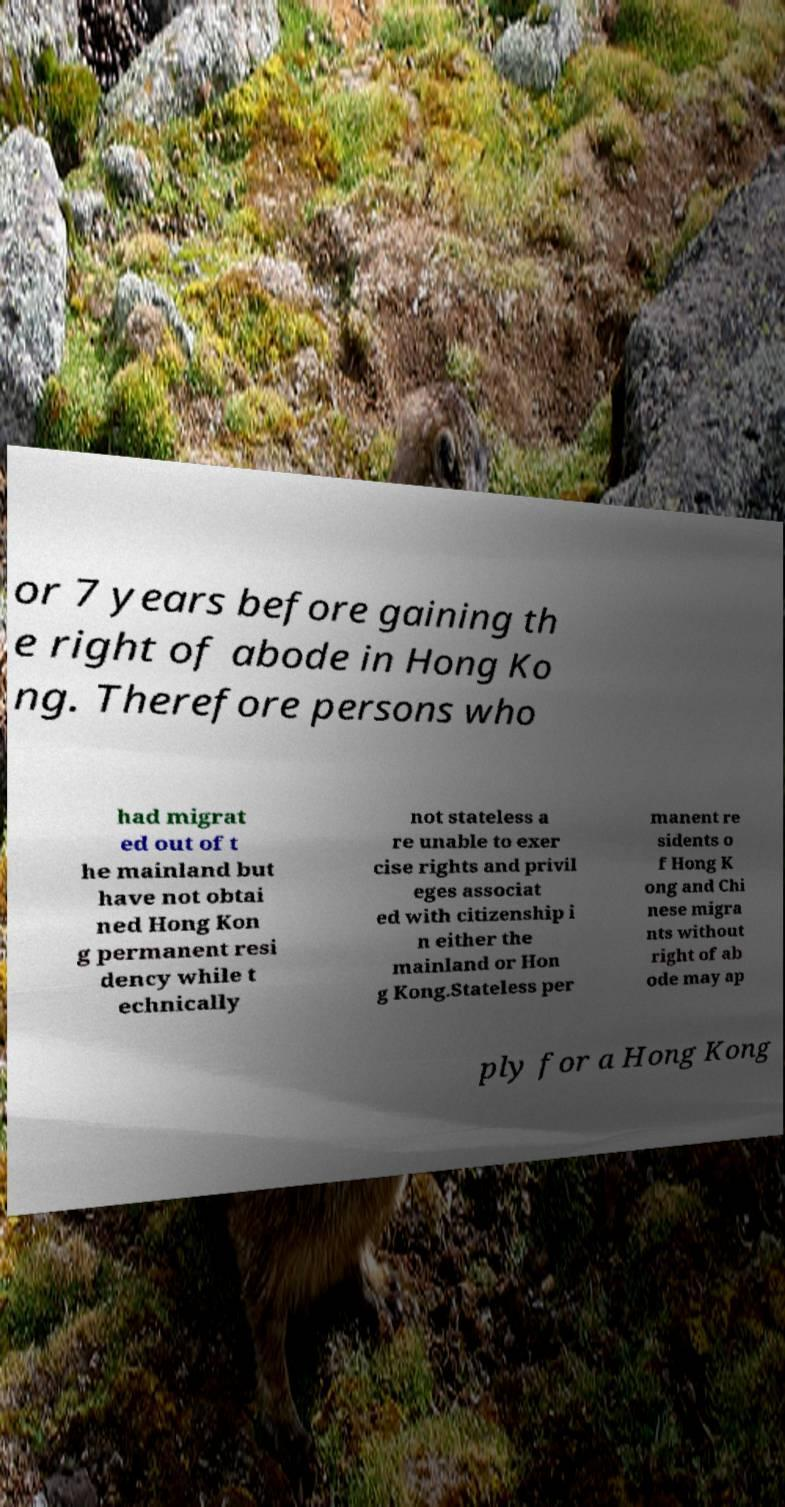Can you read and provide the text displayed in the image?This photo seems to have some interesting text. Can you extract and type it out for me? or 7 years before gaining th e right of abode in Hong Ko ng. Therefore persons who had migrat ed out of t he mainland but have not obtai ned Hong Kon g permanent resi dency while t echnically not stateless a re unable to exer cise rights and privil eges associat ed with citizenship i n either the mainland or Hon g Kong.Stateless per manent re sidents o f Hong K ong and Chi nese migra nts without right of ab ode may ap ply for a Hong Kong 